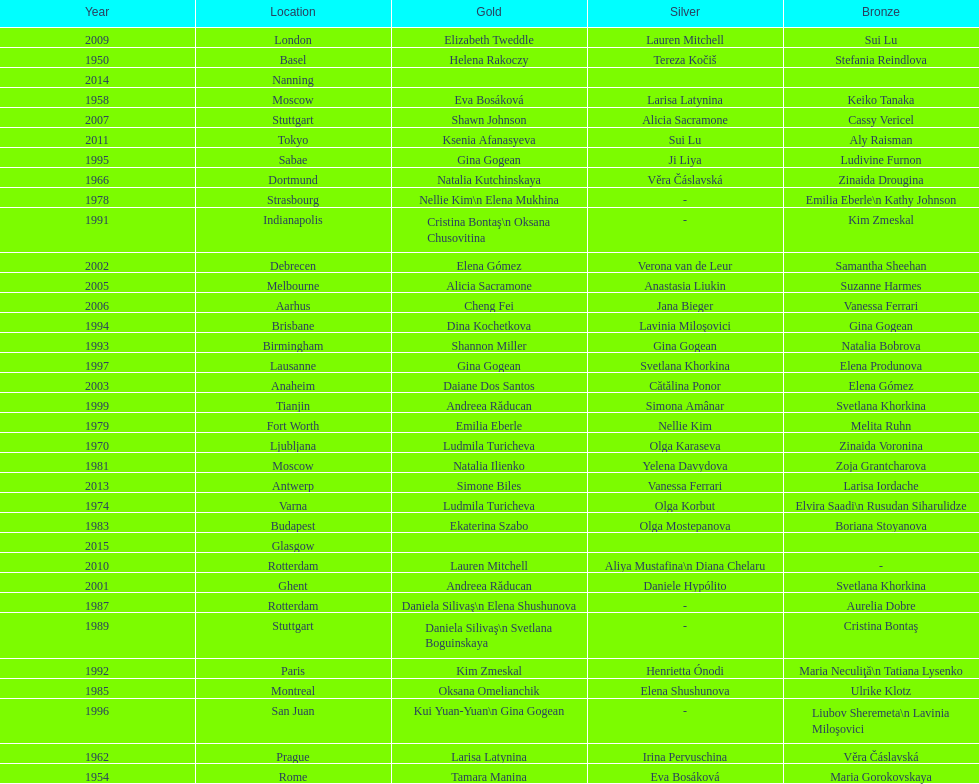As of 2013, what is the total number of floor exercise gold medals won by american women at the world championships? 5. 